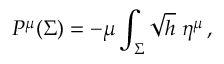<formula> <loc_0><loc_0><loc_500><loc_500>P ^ { \mu } ( \Sigma ) = - \mu \int _ { \Sigma } \sqrt { h } \, \eta ^ { \mu } \, ,</formula> 